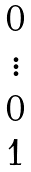<formula> <loc_0><loc_0><loc_500><loc_500>\begin{matrix} 0 \\ \vdots \\ 0 \\ 1 \end{matrix}</formula> 